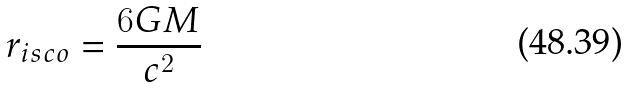<formula> <loc_0><loc_0><loc_500><loc_500>r _ { i s c o } = \frac { 6 G M } { c ^ { 2 } }</formula> 